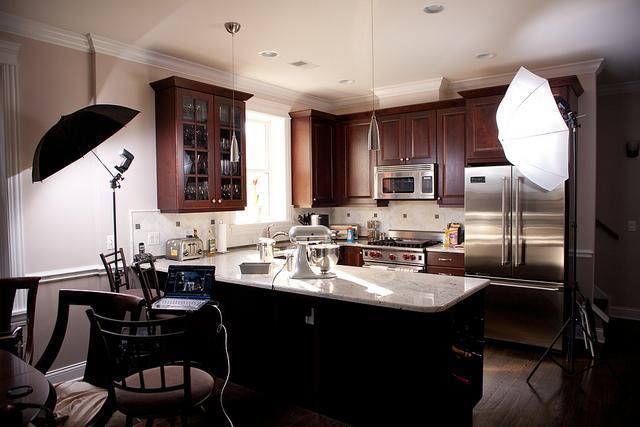How many chairs are there?
Give a very brief answer. 2. How many dining tables can be seen?
Give a very brief answer. 2. How many umbrellas are there?
Give a very brief answer. 2. 